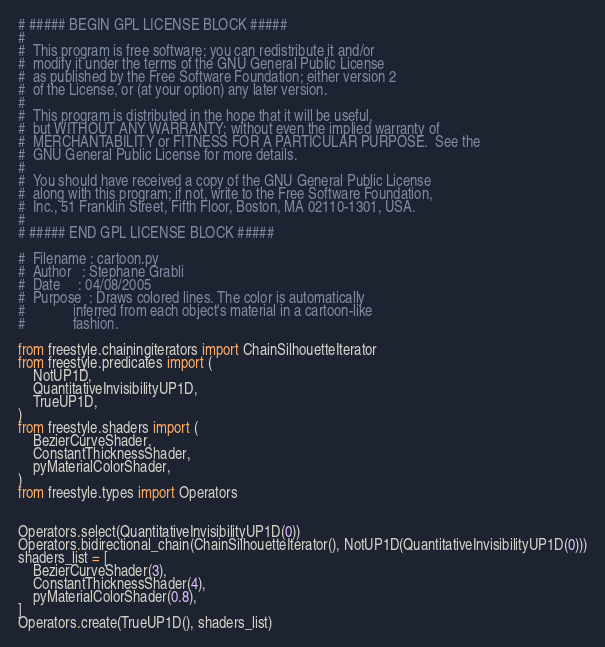<code> <loc_0><loc_0><loc_500><loc_500><_Python_># ##### BEGIN GPL LICENSE BLOCK #####
#
#  This program is free software; you can redistribute it and/or
#  modify it under the terms of the GNU General Public License
#  as published by the Free Software Foundation; either version 2
#  of the License, or (at your option) any later version.
#
#  This program is distributed in the hope that it will be useful,
#  but WITHOUT ANY WARRANTY; without even the implied warranty of
#  MERCHANTABILITY or FITNESS FOR A PARTICULAR PURPOSE.  See the
#  GNU General Public License for more details.
#
#  You should have received a copy of the GNU General Public License
#  along with this program; if not, write to the Free Software Foundation,
#  Inc., 51 Franklin Street, Fifth Floor, Boston, MA 02110-1301, USA.
#
# ##### END GPL LICENSE BLOCK #####

#  Filename : cartoon.py
#  Author   : Stephane Grabli
#  Date     : 04/08/2005
#  Purpose  : Draws colored lines. The color is automatically
#             inferred from each object's material in a cartoon-like
#             fashion.

from freestyle.chainingiterators import ChainSilhouetteIterator
from freestyle.predicates import (
    NotUP1D,
    QuantitativeInvisibilityUP1D,
    TrueUP1D,
)
from freestyle.shaders import (
    BezierCurveShader,
    ConstantThicknessShader,
    pyMaterialColorShader,
)
from freestyle.types import Operators


Operators.select(QuantitativeInvisibilityUP1D(0))
Operators.bidirectional_chain(ChainSilhouetteIterator(), NotUP1D(QuantitativeInvisibilityUP1D(0)))
shaders_list = [
    BezierCurveShader(3),
    ConstantThicknessShader(4),
    pyMaterialColorShader(0.8),
]
Operators.create(TrueUP1D(), shaders_list)
</code> 